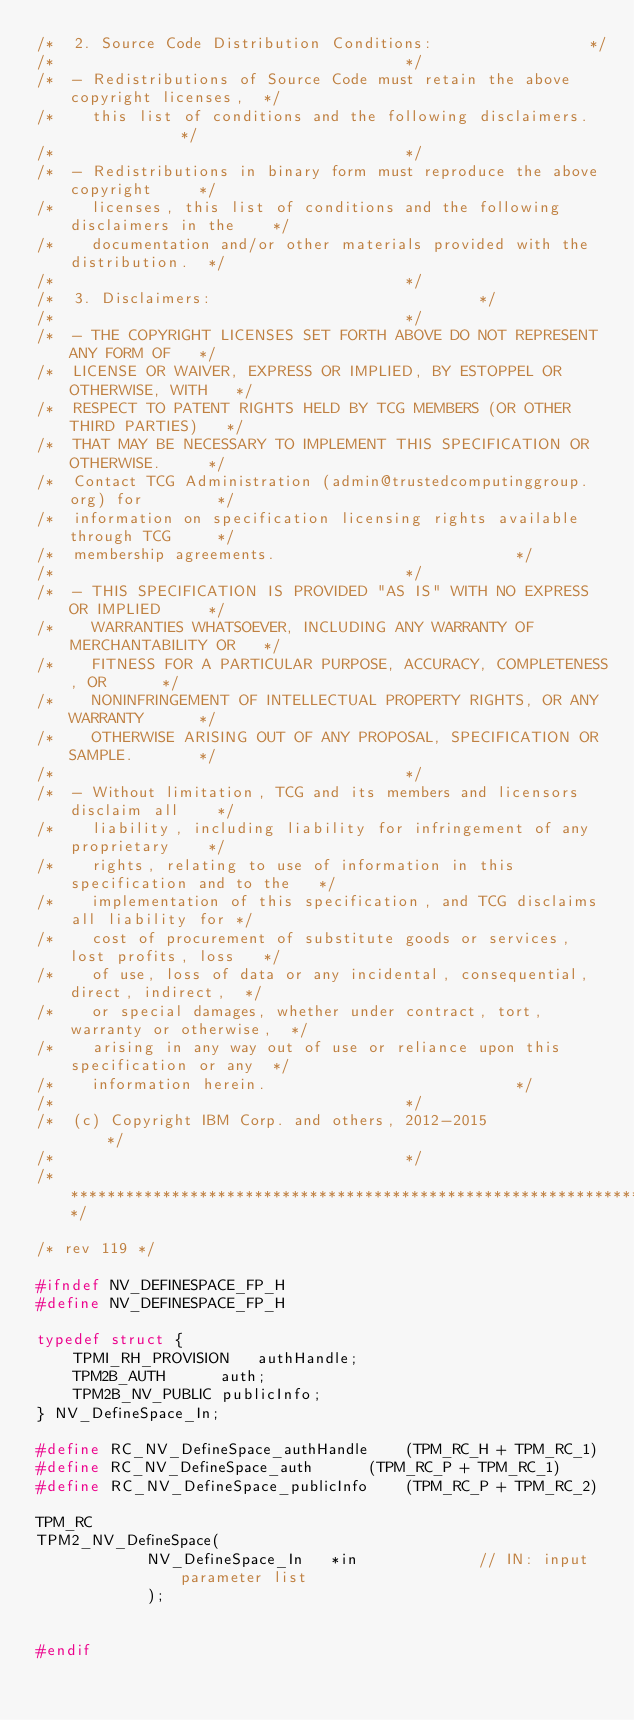<code> <loc_0><loc_0><loc_500><loc_500><_C_>/*  2. Source Code Distribution Conditions:					*/
/*										*/
/*  - Redistributions of Source Code must retain the above copyright licenses, 	*/
/*    this list of conditions and the following disclaimers.			*/
/*										*/
/*  - Redistributions in binary form must reproduce the above copyright 	*/
/*    licenses, this list of conditions	and the following disclaimers in the 	*/
/*    documentation and/or other materials provided with the distribution.	*/
/*										*/
/*  3. Disclaimers:								*/
/*										*/
/*  - THE COPYRIGHT LICENSES SET FORTH ABOVE DO NOT REPRESENT ANY FORM OF	*/
/*  LICENSE OR WAIVER, EXPRESS OR IMPLIED, BY ESTOPPEL OR OTHERWISE, WITH	*/
/*  RESPECT TO PATENT RIGHTS HELD BY TCG MEMBERS (OR OTHER THIRD PARTIES)	*/
/*  THAT MAY BE NECESSARY TO IMPLEMENT THIS SPECIFICATION OR OTHERWISE.		*/
/*  Contact TCG Administration (admin@trustedcomputinggroup.org) for 		*/
/*  information on specification licensing rights available through TCG 	*/
/*  membership agreements.							*/
/*										*/
/*  - THIS SPECIFICATION IS PROVIDED "AS IS" WITH NO EXPRESS OR IMPLIED 	*/
/*    WARRANTIES WHATSOEVER, INCLUDING ANY WARRANTY OF MERCHANTABILITY OR 	*/
/*    FITNESS FOR A PARTICULAR PURPOSE, ACCURACY, COMPLETENESS, OR 		*/
/*    NONINFRINGEMENT OF INTELLECTUAL PROPERTY RIGHTS, OR ANY WARRANTY 		*/
/*    OTHERWISE ARISING OUT OF ANY PROPOSAL, SPECIFICATION OR SAMPLE.		*/
/*										*/
/*  - Without limitation, TCG and its members and licensors disclaim all 	*/
/*    liability, including liability for infringement of any proprietary 	*/
/*    rights, relating to use of information in this specification and to the	*/
/*    implementation of this specification, and TCG disclaims all liability for	*/
/*    cost of procurement of substitute goods or services, lost profits, loss 	*/
/*    of use, loss of data or any incidental, consequential, direct, indirect, 	*/
/*    or special damages, whether under contract, tort, warranty or otherwise, 	*/
/*    arising in any way out of use or reliance upon this specification or any 	*/
/*    information herein.							*/
/*										*/
/*  (c) Copyright IBM Corp. and others, 2012-2015				*/
/*										*/
/********************************************************************************/

/* rev 119 */

#ifndef NV_DEFINESPACE_FP_H
#define NV_DEFINESPACE_FP_H

typedef struct {
    TPMI_RH_PROVISION	authHandle;
    TPM2B_AUTH		auth;
    TPM2B_NV_PUBLIC	publicInfo;
} NV_DefineSpace_In;

#define RC_NV_DefineSpace_authHandle 	(TPM_RC_H + TPM_RC_1)
#define RC_NV_DefineSpace_auth 		(TPM_RC_P + TPM_RC_1)
#define RC_NV_DefineSpace_publicInfo 	(TPM_RC_P + TPM_RC_2)

TPM_RC
TPM2_NV_DefineSpace(
		    NV_DefineSpace_In   *in             // IN: input parameter list
		    );


#endif
</code> 